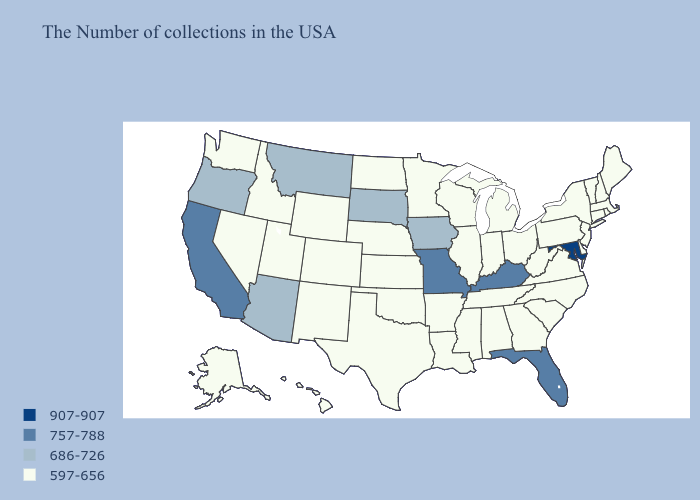Does Kentucky have the lowest value in the South?
Keep it brief. No. Does Maryland have the lowest value in the South?
Be succinct. No. What is the value of Delaware?
Give a very brief answer. 597-656. Among the states that border Massachusetts , which have the highest value?
Give a very brief answer. Rhode Island, New Hampshire, Vermont, Connecticut, New York. Does New Jersey have a higher value than Minnesota?
Write a very short answer. No. What is the value of Maine?
Keep it brief. 597-656. Name the states that have a value in the range 907-907?
Quick response, please. Maryland. Which states have the lowest value in the West?
Concise answer only. Wyoming, Colorado, New Mexico, Utah, Idaho, Nevada, Washington, Alaska, Hawaii. Does New Hampshire have a higher value than Utah?
Be succinct. No. What is the value of Maine?
Write a very short answer. 597-656. What is the value of North Carolina?
Be succinct. 597-656. Which states have the lowest value in the USA?
Write a very short answer. Maine, Massachusetts, Rhode Island, New Hampshire, Vermont, Connecticut, New York, New Jersey, Delaware, Pennsylvania, Virginia, North Carolina, South Carolina, West Virginia, Ohio, Georgia, Michigan, Indiana, Alabama, Tennessee, Wisconsin, Illinois, Mississippi, Louisiana, Arkansas, Minnesota, Kansas, Nebraska, Oklahoma, Texas, North Dakota, Wyoming, Colorado, New Mexico, Utah, Idaho, Nevada, Washington, Alaska, Hawaii. What is the highest value in the Northeast ?
Concise answer only. 597-656. Does Illinois have the same value as Minnesota?
Write a very short answer. Yes. What is the value of New Hampshire?
Concise answer only. 597-656. 